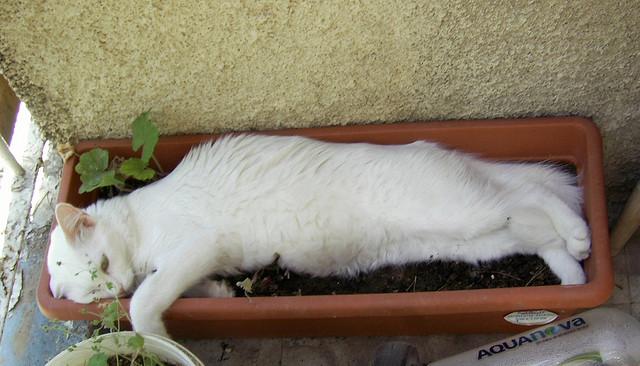What is this cat laying in?
Concise answer only. Planter. What color is the cat?
Write a very short answer. White. What colors are the cat?
Concise answer only. White. What is cat lying on?
Be succinct. Plant. Does the cat like dirt?
Quick response, please. Yes. 